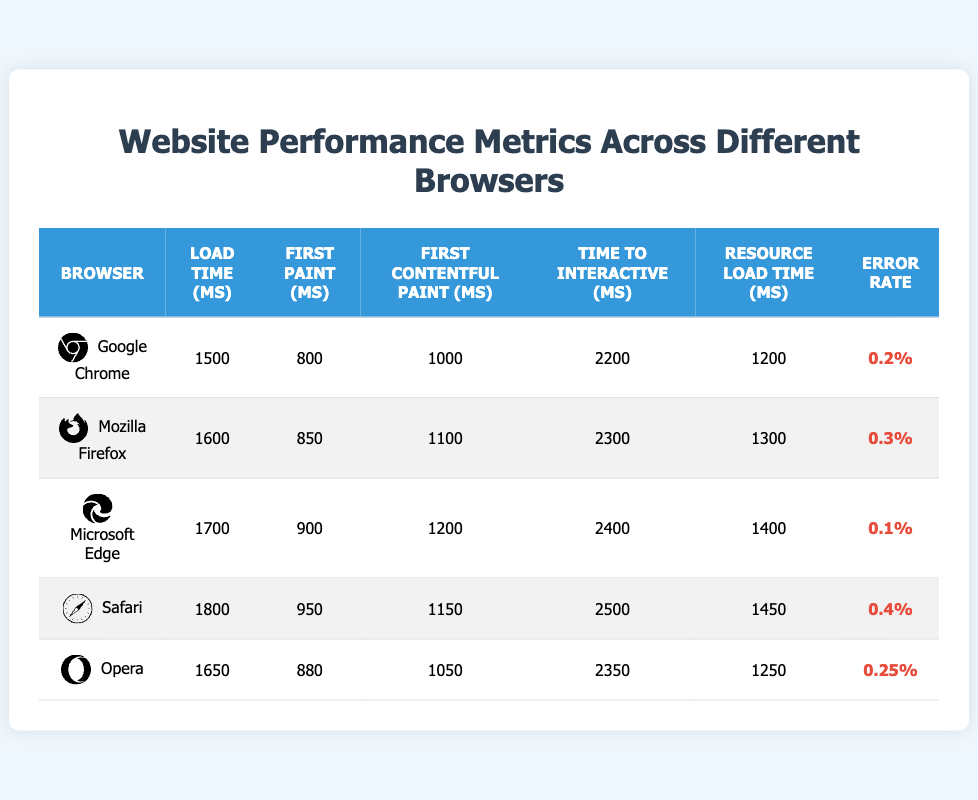What is the load time for Google Chrome? The load time for Google Chrome can be found directly in the table under the "Load Time (ms)" column for the row corresponding to "Google Chrome," which shows the value 1500 milliseconds.
Answer: 1500 ms Which browser has the highest error rate? To find the highest error rate, we check the "Error Rate" column for all browsers. The highest value is 0.4% for Safari.
Answer: Safari What is the average resource load time across all browsers? First, we need to sum the resource load times for each browser: 1200 + 1300 + 1400 + 1450 + 1250 = 6600 ms. Then, we divide by the number of browsers, which is 5, giving us an average of 6600 / 5 = 1320 ms.
Answer: 1320 ms Does Microsoft Edge have a faster load time than Safari? We compare the load time of Microsoft Edge (1700 ms) and Safari (1800 ms). Since 1700 is less than 1800, Microsoft Edge has a faster load time than Safari.
Answer: Yes What is the difference in time to interactive between Google Chrome and Mozilla Firefox? The time to interactive for Google Chrome is 2200 ms and for Mozilla Firefox is 2300 ms. The difference is 2300 ms - 2200 ms = 100 ms.
Answer: 100 ms Do any browsers have a time to first contentful paint greater than 1100 ms? We examine the "First Contentful Paint (ms)" column: Google Chrome (1000 ms), Mozilla Firefox (1100 ms), Microsoft Edge (1200 ms), Safari (1150 ms), and Opera (1050 ms). All browsers except Google Chrome have above 1100 ms.
Answer: Yes What is the median load time of all listed browsers? First, list the load times in ascending order: 1500, 1600, 1650, 1700, 1800. The number of values is odd (5), so the median is the middle value, which is the third value: 1650 ms.
Answer: 1650 ms Which browser has both the shortest load time and the fastest resource load time? Reviewing the load times and resource load times: Google Chrome has 1500 ms for load time and 1200 ms for resource load time. Opera has 1650 ms for load time and 1250 ms for resource load time, while others have higher load times. Thus, Google Chrome has both the shortest load time and fastest resource load time.
Answer: Google Chrome Is the first paint time for Opera less than that of Microsoft Edge? Comparing the "First Paint (ms)" values: Opera has 880 ms and Microsoft Edge has 900 ms. Since 880 ms is less than 900 ms, we can conclude that Opera's first paint time is indeed less.
Answer: Yes 